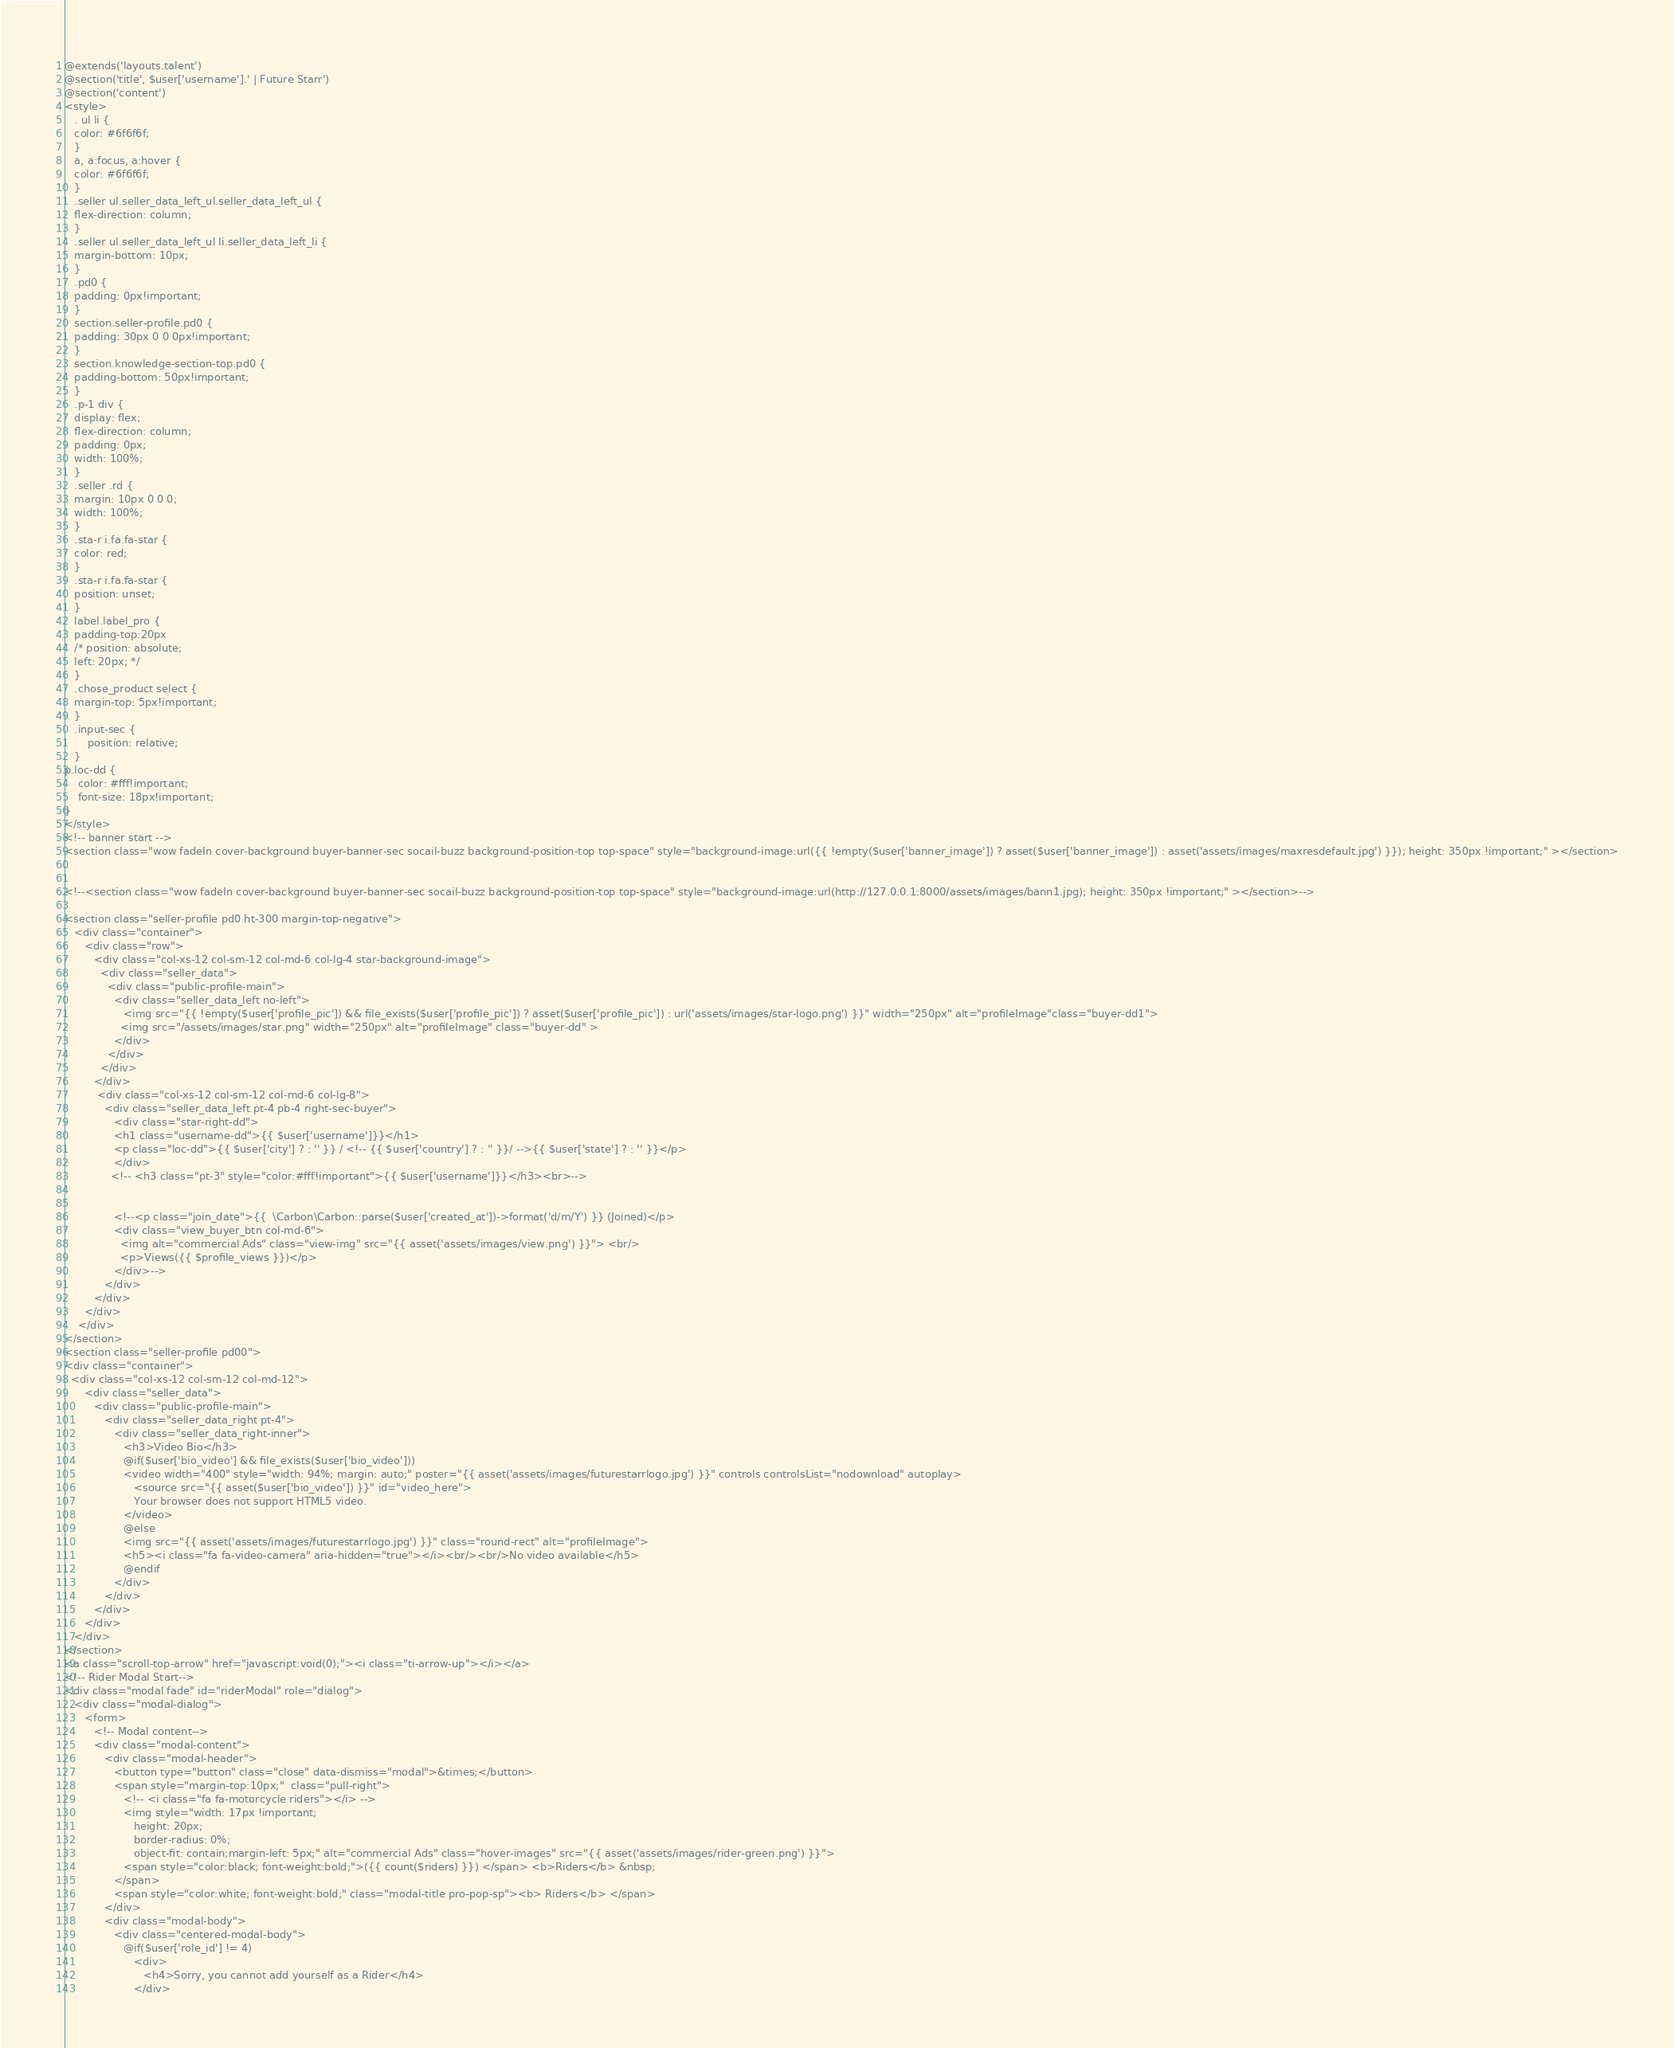<code> <loc_0><loc_0><loc_500><loc_500><_PHP_>@extends('layouts.talent') 
@section('title', $user['username'].' | Future Starr')
@section('content')
<style>
   . ul li {
   color: #6f6f6f;
   }
   a, a:focus, a:hover {
   color: #6f6f6f;
   }
   .seller ul.seller_data_left_ul.seller_data_left_ul {
   flex-direction: column;
   }
   .seller ul.seller_data_left_ul li.seller_data_left_li {
   margin-bottom: 10px;
   }
   .pd0 {
   padding: 0px!important;
   }
   section.seller-profile.pd0 {
   padding: 30px 0 0 0px!important;
   }
   section.knowledge-section-top.pd0 {
   padding-bottom: 50px!important;
   }
   .p-1 div {
   display: flex;
   flex-direction: column;
   padding: 0px;
   width: 100%;
   }
   .seller .rd {
   margin: 10px 0 0 0;
   width: 100%;
   }
   .sta-r i.fa.fa-star {
   color: red;
   }
   .sta-r i.fa.fa-star {
   position: unset;
   }
   label.label_pro {
   padding-top:20px   
   /* position: absolute;
   left: 20px; */
   }
   .chose_product select {
   margin-top: 5px!important;
   }
   .input-sec {
       position: relative;
   }
p.loc-dd {
    color: #fff!important;
    font-size: 18px!important;
}
</style>
<!-- banner start -->
<section class="wow fadeIn cover-background buyer-banner-sec socail-buzz background-position-top top-space" style="background-image:url({{ !empty($user['banner_image']) ? asset($user['banner_image']) : asset('assets/images/maxresdefault.jpg') }}); height: 350px !important;" ></section>


<!--<section class="wow fadeIn cover-background buyer-banner-sec socail-buzz background-position-top top-space" style="background-image:url(http://127.0.0.1:8000/assets/images/bann1.jpg); height: 350px !important;" ></section>-->

<section class="seller-profile pd0 ht-300 margin-top-negative">
   <div class="container">
      <div class="row">
         <div class="col-xs-12 col-sm-12 col-md-6 col-lg-4 star-background-image">
           <div class="seller_data">
             <div class="public-profile-main">
               <div class="seller_data_left no-left">
                  <img src="{{ !empty($user['profile_pic']) && file_exists($user['profile_pic']) ? asset($user['profile_pic']) : url('assets/images/star-logo.png') }}" width="250px" alt="profileImage"class="buyer-dd1">
                 <img src="/assets/images/star.png" width="250px" alt="profileImage" class="buyer-dd" >
               </div>
             </div>
           </div>
         </div>
          <div class="col-xs-12 col-sm-12 col-md-6 col-lg-8">
            <div class="seller_data_left pt-4 pb-4 right-sec-buyer"> 
               <div class="star-right-dd">
               <h1 class="username-dd">{{ $user['username']}}</h1>
               <p class="loc-dd">{{ $user['city'] ? : '' }} / <!-- {{ $user['country'] ? : '' }}/ -->{{ $user['state'] ? : '' }}</p>
               </div>
              <!-- <h3 class="pt-3" style="color:#fff!important">{{ $user['username']}}</h3><br>-->
              
      
               <!--<p class="join_date">{{  \Carbon\Carbon::parse($user['created_at'])->format('d/m/Y') }} (Joined)</p>
               <div class="view_buyer_btn col-md-6">
                 <img alt="commercial Ads" class="view-img" src="{{ asset('assets/images/view.png') }}"> <br/>
                 <p>Views({{ $profile_views }})</p>
               </div>-->
            </div>
         </div>
      </div>
    </div>
</section> 
<section class="seller-profile pd00">
<div class="container">
  <div class="col-xs-12 col-sm-12 col-md-12">
      <div class="seller_data">
         <div class="public-profile-main">
            <div class="seller_data_right pt-4">
               <div class="seller_data_right-inner">
                  <h3>Video Bio</h3>
                  @if($user['bio_video'] && file_exists($user['bio_video']))
                  <video width="400" style="width: 94%; margin: auto;" poster="{{ asset('assets/images/futurestarrlogo.jpg') }}" controls controlsList="nodownload" autoplay>
                     <source src="{{ asset($user['bio_video']) }}" id="video_here">
                     Your browser does not support HTML5 video.
                  </video>
                  @else
                  <img src="{{ asset('assets/images/futurestarrlogo.jpg') }}" class="round-rect" alt="profileImage">
                  <h5><i class="fa fa-video-camera" aria-hidden="true"></i><br/><br/>No video available</h5>
                  @endif
               </div>
            </div>
         </div>
      </div>
   </div>
</section>
<a class="scroll-top-arrow" href="javascript:void(0);"><i class="ti-arrow-up"></i></a>
<!-- Rider Modal Start-->
<div class="modal fade" id="riderModal" role="dialog">
   <div class="modal-dialog">
      <form>
         <!-- Modal content-->
         <div class="modal-content">
            <div class="modal-header">
               <button type="button" class="close" data-dismiss="modal">&times;</button>
               <span style="margin-top:10px;"  class="pull-right">
                  <!-- <i class="fa fa-motorcycle riders"></i> -->
                  <img style="width: 17px !important;
                     height: 20px;
                     border-radius: 0%;
                     object-fit: contain;margin-left: 5px;" alt="commercial Ads" class="hover-images" src="{{ asset('assets/images/rider-green.png') }}">
                  <span style="color:black; font-weight:bold;">({{ count($riders) }}) </span> <b>Riders</b> &nbsp;
               </span>
               <span style="color:white; font-weight:bold;" class="modal-title pro-pop-sp"><b> Riders</b> </span>
            </div>
            <div class="modal-body">
               <div class="centered-modal-body">
                  @if($user['role_id'] != 4)
                     <div>
                        <h4>Sorry, you cannot add yourself as a Rider</h4>
                     </div></code> 